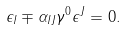Convert formula to latex. <formula><loc_0><loc_0><loc_500><loc_500>\epsilon _ { I } \mp \alpha _ { I J } \gamma ^ { 0 } \epsilon ^ { J } = 0 .</formula> 